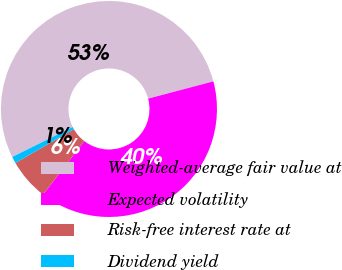Convert chart. <chart><loc_0><loc_0><loc_500><loc_500><pie_chart><fcel>Weighted-average fair value at<fcel>Expected volatility<fcel>Risk-free interest rate at<fcel>Dividend yield<nl><fcel>53.21%<fcel>39.56%<fcel>6.22%<fcel>1.0%<nl></chart> 